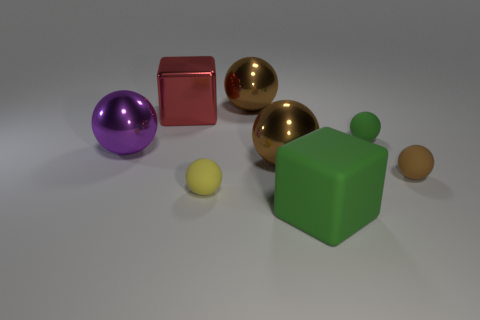Subtract all gray cubes. How many brown balls are left? 3 Subtract all big purple balls. How many balls are left? 5 Subtract all yellow spheres. How many spheres are left? 5 Subtract all red spheres. Subtract all green cubes. How many spheres are left? 6 Add 2 yellow objects. How many objects exist? 10 Subtract all balls. How many objects are left? 2 Subtract 3 brown balls. How many objects are left? 5 Subtract all tiny brown things. Subtract all small brown objects. How many objects are left? 6 Add 1 red metal cubes. How many red metal cubes are left? 2 Add 7 brown shiny balls. How many brown shiny balls exist? 9 